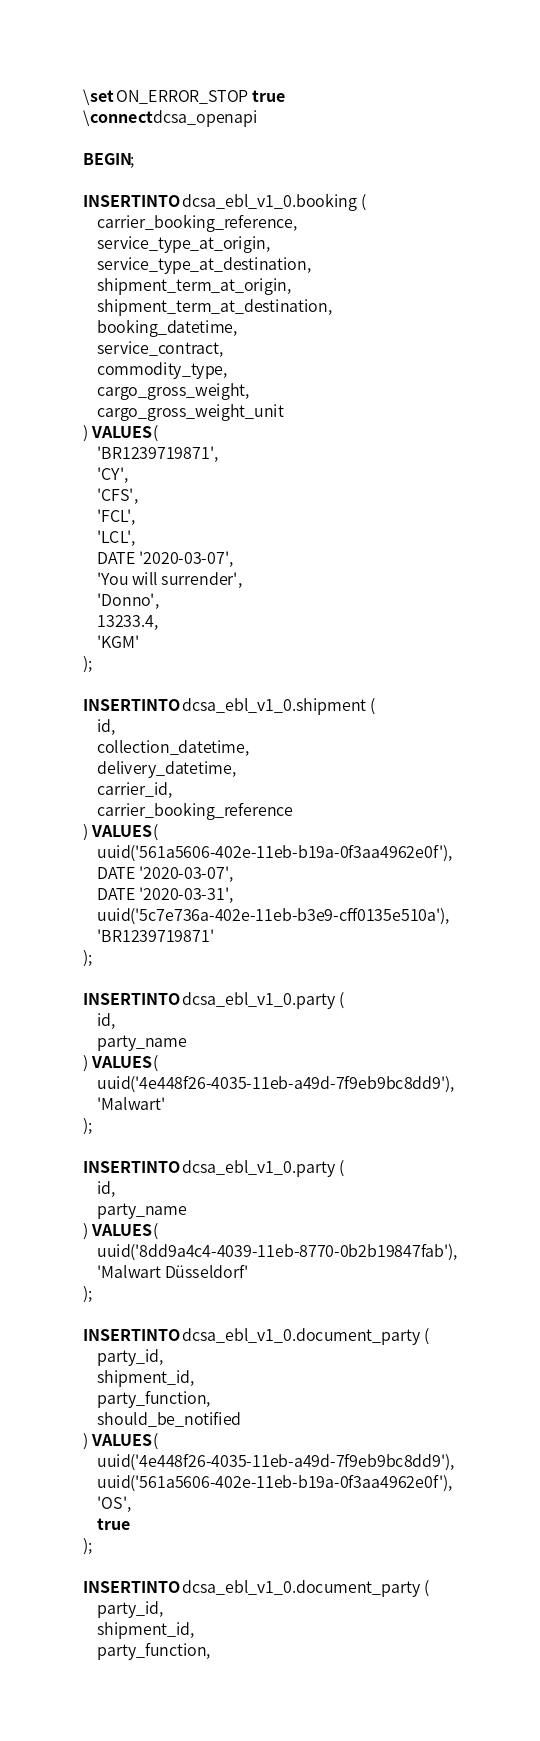Convert code to text. <code><loc_0><loc_0><loc_500><loc_500><_SQL_>\set ON_ERROR_STOP true
\connect dcsa_openapi

BEGIN;

INSERT INTO dcsa_ebl_v1_0.booking (
	carrier_booking_reference,
	service_type_at_origin,
	service_type_at_destination,
	shipment_term_at_origin,
	shipment_term_at_destination,
	booking_datetime,
	service_contract,
	commodity_type,
	cargo_gross_weight,
	cargo_gross_weight_unit
) VALUES (
    'BR1239719871',
    'CY',
    'CFS',
    'FCL',
    'LCL',
    DATE '2020-03-07',
    'You will surrender',
    'Donno',
    13233.4,
    'KGM'
);

INSERT INTO dcsa_ebl_v1_0.shipment (
    id,
    collection_datetime,
    delivery_datetime,
    carrier_id,
    carrier_booking_reference
) VALUES (
    uuid('561a5606-402e-11eb-b19a-0f3aa4962e0f'),
    DATE '2020-03-07',
    DATE '2020-03-31',
    uuid('5c7e736a-402e-11eb-b3e9-cff0135e510a'),
    'BR1239719871'
);

INSERT INTO dcsa_ebl_v1_0.party (
    id,
    party_name
) VALUES (
    uuid('4e448f26-4035-11eb-a49d-7f9eb9bc8dd9'),
    'Malwart'
);

INSERT INTO dcsa_ebl_v1_0.party (
    id,
    party_name
) VALUES (
    uuid('8dd9a4c4-4039-11eb-8770-0b2b19847fab'),
    'Malwart Düsseldorf'
);

INSERT INTO dcsa_ebl_v1_0.document_party (
    party_id,
    shipment_id,
    party_function,
    should_be_notified
) VALUES (
    uuid('4e448f26-4035-11eb-a49d-7f9eb9bc8dd9'),
    uuid('561a5606-402e-11eb-b19a-0f3aa4962e0f'),
    'OS',
    true
);

INSERT INTO dcsa_ebl_v1_0.document_party (
    party_id,
    shipment_id,
    party_function,</code> 